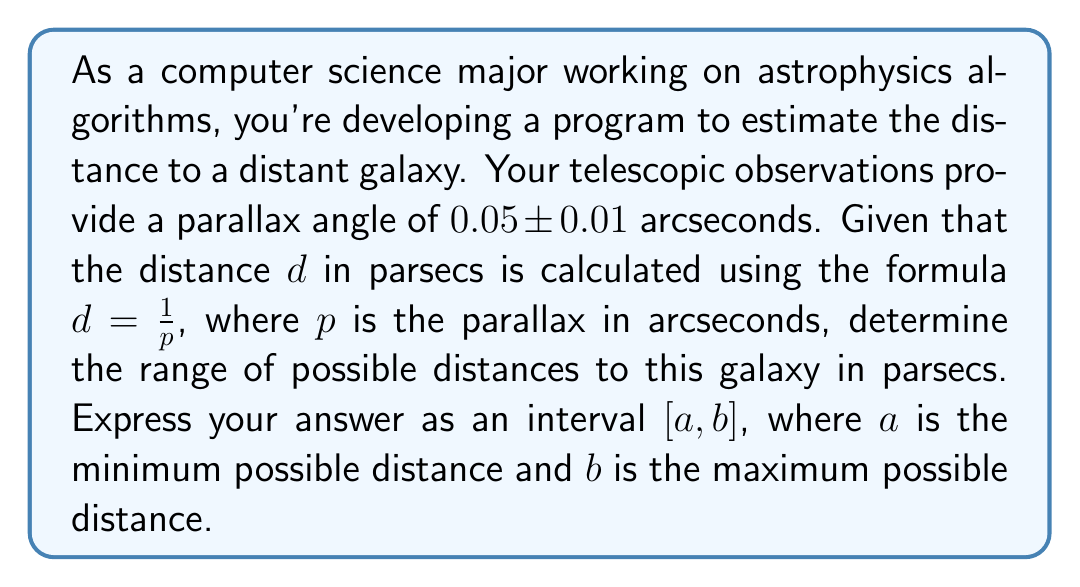Help me with this question. To solve this problem, we need to consider the lower and upper bounds of the parallax measurement and how they affect the calculated distance.

1. Given information:
   - Parallax angle: $0.05 \pm 0.01$ arcseconds
   - Distance formula: $d = \frac{1}{p}$, where $d$ is in parsecs and $p$ is in arcseconds

2. Calculate the range of possible parallax values:
   - Minimum parallax: $0.05 - 0.01 = 0.04$ arcseconds
   - Maximum parallax: $0.05 + 0.01 = 0.06$ arcseconds

3. Calculate the maximum distance (corresponding to minimum parallax):
   $$d_{max} = \frac{1}{p_{min}} = \frac{1}{0.04} = 25 \text{ parsecs}$$

4. Calculate the minimum distance (corresponding to maximum parallax):
   $$d_{min} = \frac{1}{p_{max}} = \frac{1}{0.06} \approx 16.67 \text{ parsecs}$$

5. Express the range of possible distances as an interval:
   $[16.67, 25]$ parsecs

Note that in practice, we might round these values to a reasonable number of significant figures based on the precision of our measurements. However, for this problem, we'll keep the exact calculated values.
Answer: The range of possible distances to the galaxy is $[16.67, 25]$ parsecs. 